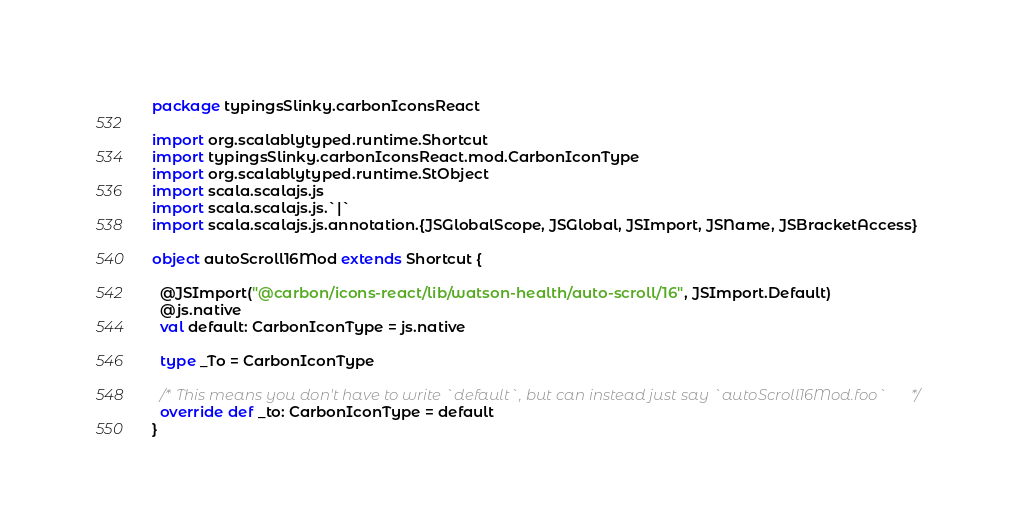Convert code to text. <code><loc_0><loc_0><loc_500><loc_500><_Scala_>package typingsSlinky.carbonIconsReact

import org.scalablytyped.runtime.Shortcut
import typingsSlinky.carbonIconsReact.mod.CarbonIconType
import org.scalablytyped.runtime.StObject
import scala.scalajs.js
import scala.scalajs.js.`|`
import scala.scalajs.js.annotation.{JSGlobalScope, JSGlobal, JSImport, JSName, JSBracketAccess}

object autoScroll16Mod extends Shortcut {
  
  @JSImport("@carbon/icons-react/lib/watson-health/auto-scroll/16", JSImport.Default)
  @js.native
  val default: CarbonIconType = js.native
  
  type _To = CarbonIconType
  
  /* This means you don't have to write `default`, but can instead just say `autoScroll16Mod.foo` */
  override def _to: CarbonIconType = default
}
</code> 